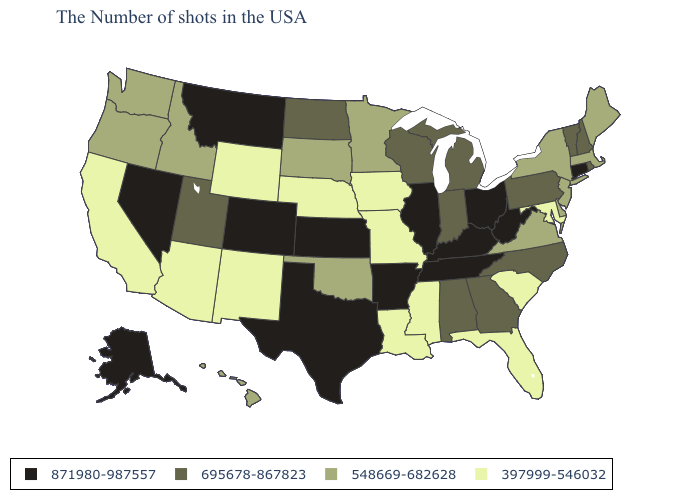What is the lowest value in states that border Arizona?
Keep it brief. 397999-546032. What is the highest value in the MidWest ?
Quick response, please. 871980-987557. Does Maine have the same value as New York?
Give a very brief answer. Yes. Name the states that have a value in the range 397999-546032?
Be succinct. Maryland, South Carolina, Florida, Mississippi, Louisiana, Missouri, Iowa, Nebraska, Wyoming, New Mexico, Arizona, California. What is the lowest value in the USA?
Concise answer only. 397999-546032. Among the states that border Oregon , does Nevada have the highest value?
Quick response, please. Yes. What is the value of Texas?
Answer briefly. 871980-987557. Which states have the highest value in the USA?
Concise answer only. Connecticut, West Virginia, Ohio, Kentucky, Tennessee, Illinois, Arkansas, Kansas, Texas, Colorado, Montana, Nevada, Alaska. Does the first symbol in the legend represent the smallest category?
Write a very short answer. No. Name the states that have a value in the range 871980-987557?
Answer briefly. Connecticut, West Virginia, Ohio, Kentucky, Tennessee, Illinois, Arkansas, Kansas, Texas, Colorado, Montana, Nevada, Alaska. What is the lowest value in the West?
Write a very short answer. 397999-546032. What is the highest value in the USA?
Quick response, please. 871980-987557. Does the map have missing data?
Give a very brief answer. No. Does Michigan have the lowest value in the MidWest?
Be succinct. No. What is the value of New York?
Concise answer only. 548669-682628. 